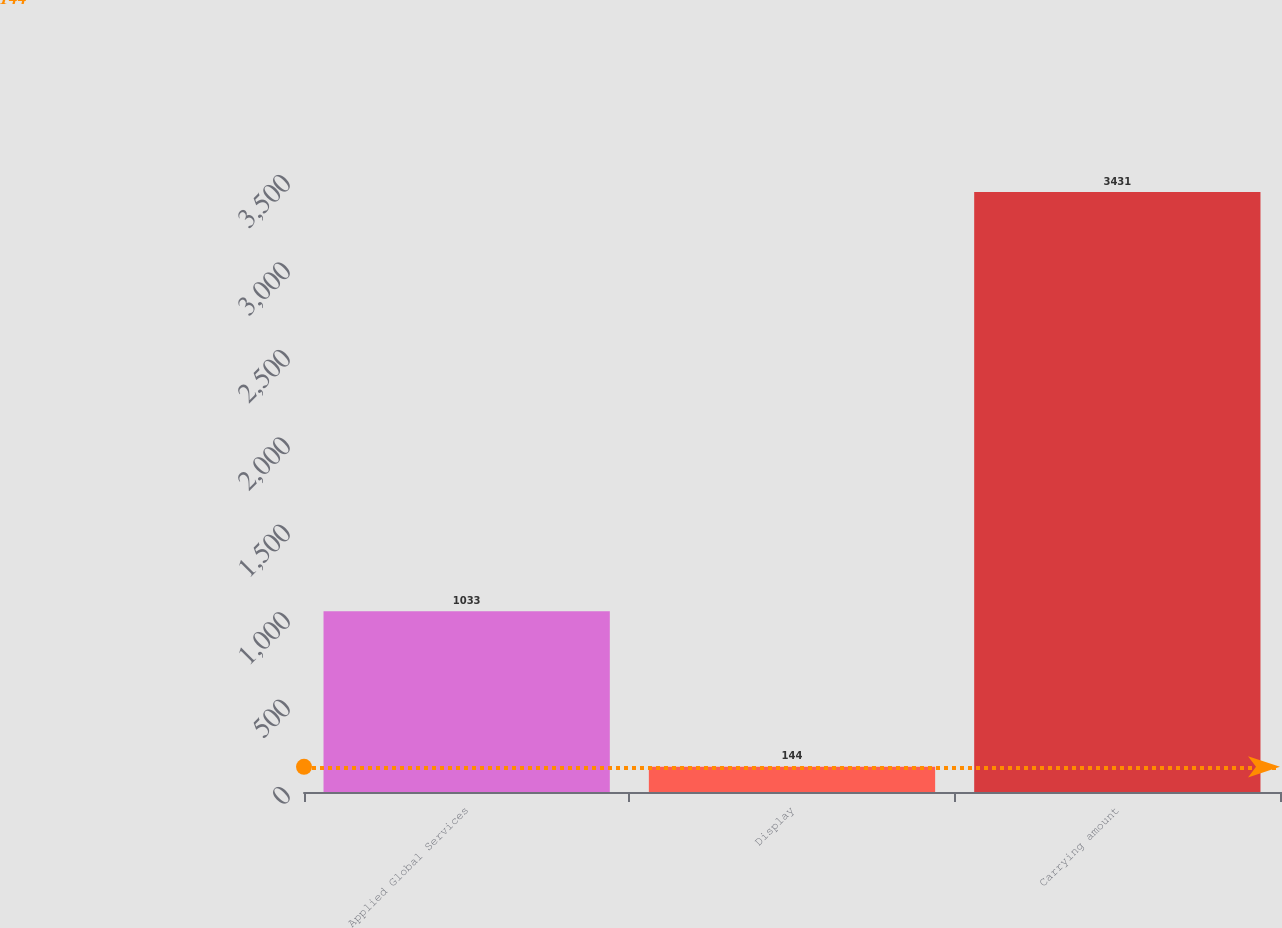Convert chart to OTSL. <chart><loc_0><loc_0><loc_500><loc_500><bar_chart><fcel>Applied Global Services<fcel>Display<fcel>Carrying amount<nl><fcel>1033<fcel>144<fcel>3431<nl></chart> 